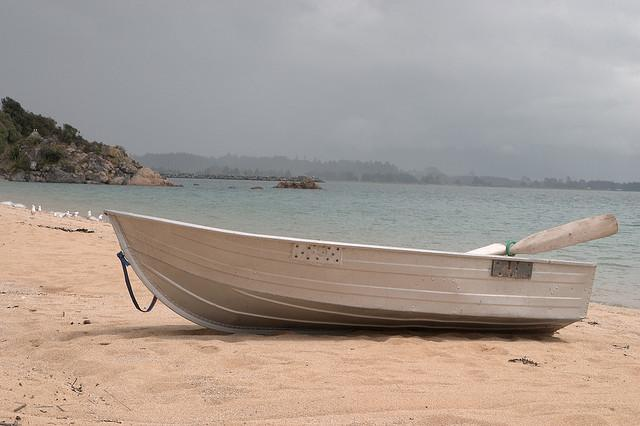What propels this boat? oar 